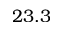Convert formula to latex. <formula><loc_0><loc_0><loc_500><loc_500>2 3 . 3</formula> 